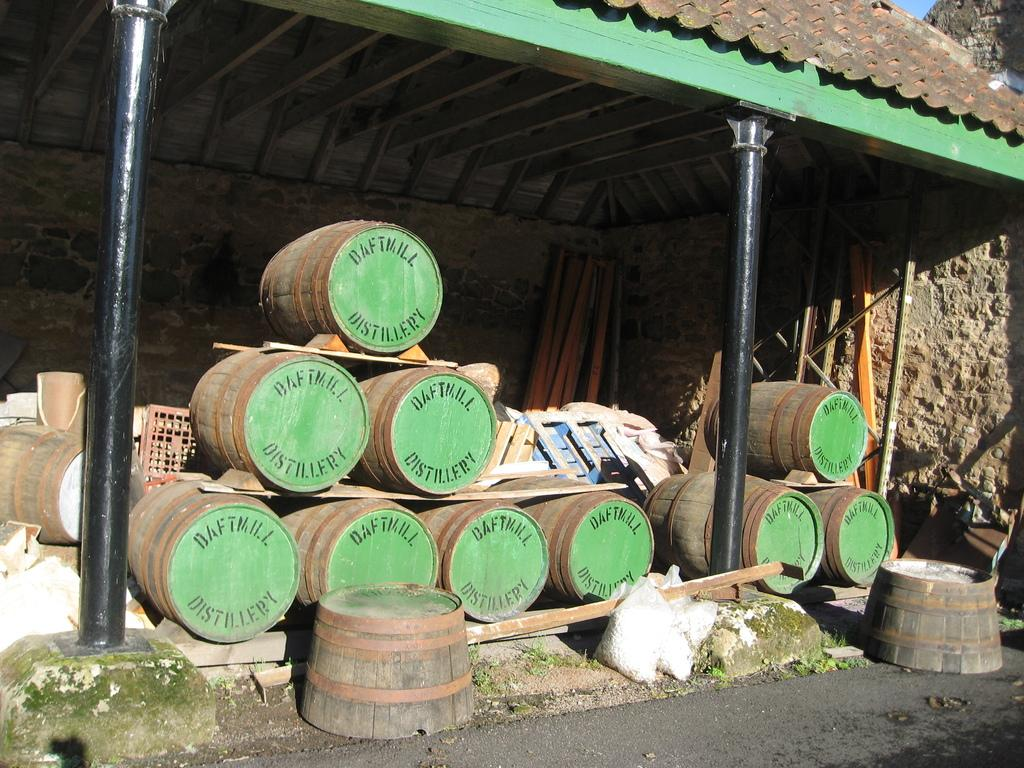What musical instruments are present in the image? There are drums in the image. What type of material are the objects under the shed made of? The wooden objects are placed under a shed. What can be seen in the background of the image? There is a road visible in the image. How many pillars are present in the image? There are two pillars in the image. Can you read the letters on the face of the clam in the image? There is no clam present in the image, and therefore no letters on its face. 